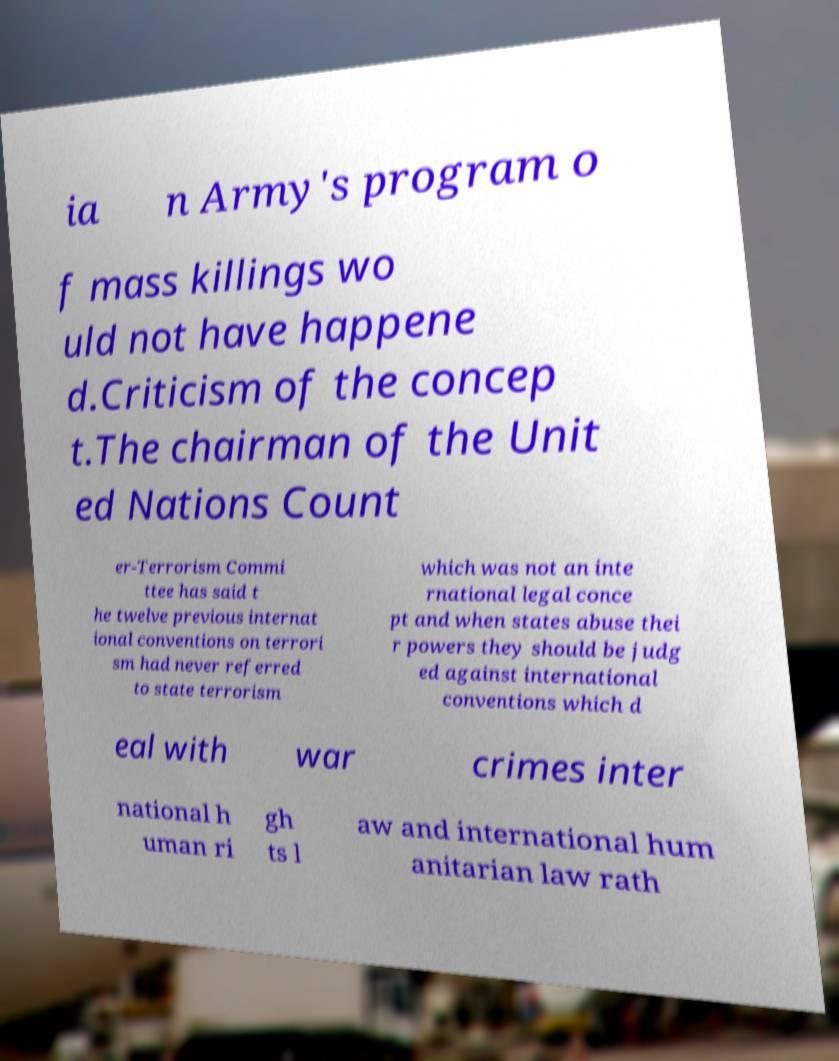Could you extract and type out the text from this image? ia n Army's program o f mass killings wo uld not have happene d.Criticism of the concep t.The chairman of the Unit ed Nations Count er-Terrorism Commi ttee has said t he twelve previous internat ional conventions on terrori sm had never referred to state terrorism which was not an inte rnational legal conce pt and when states abuse thei r powers they should be judg ed against international conventions which d eal with war crimes inter national h uman ri gh ts l aw and international hum anitarian law rath 